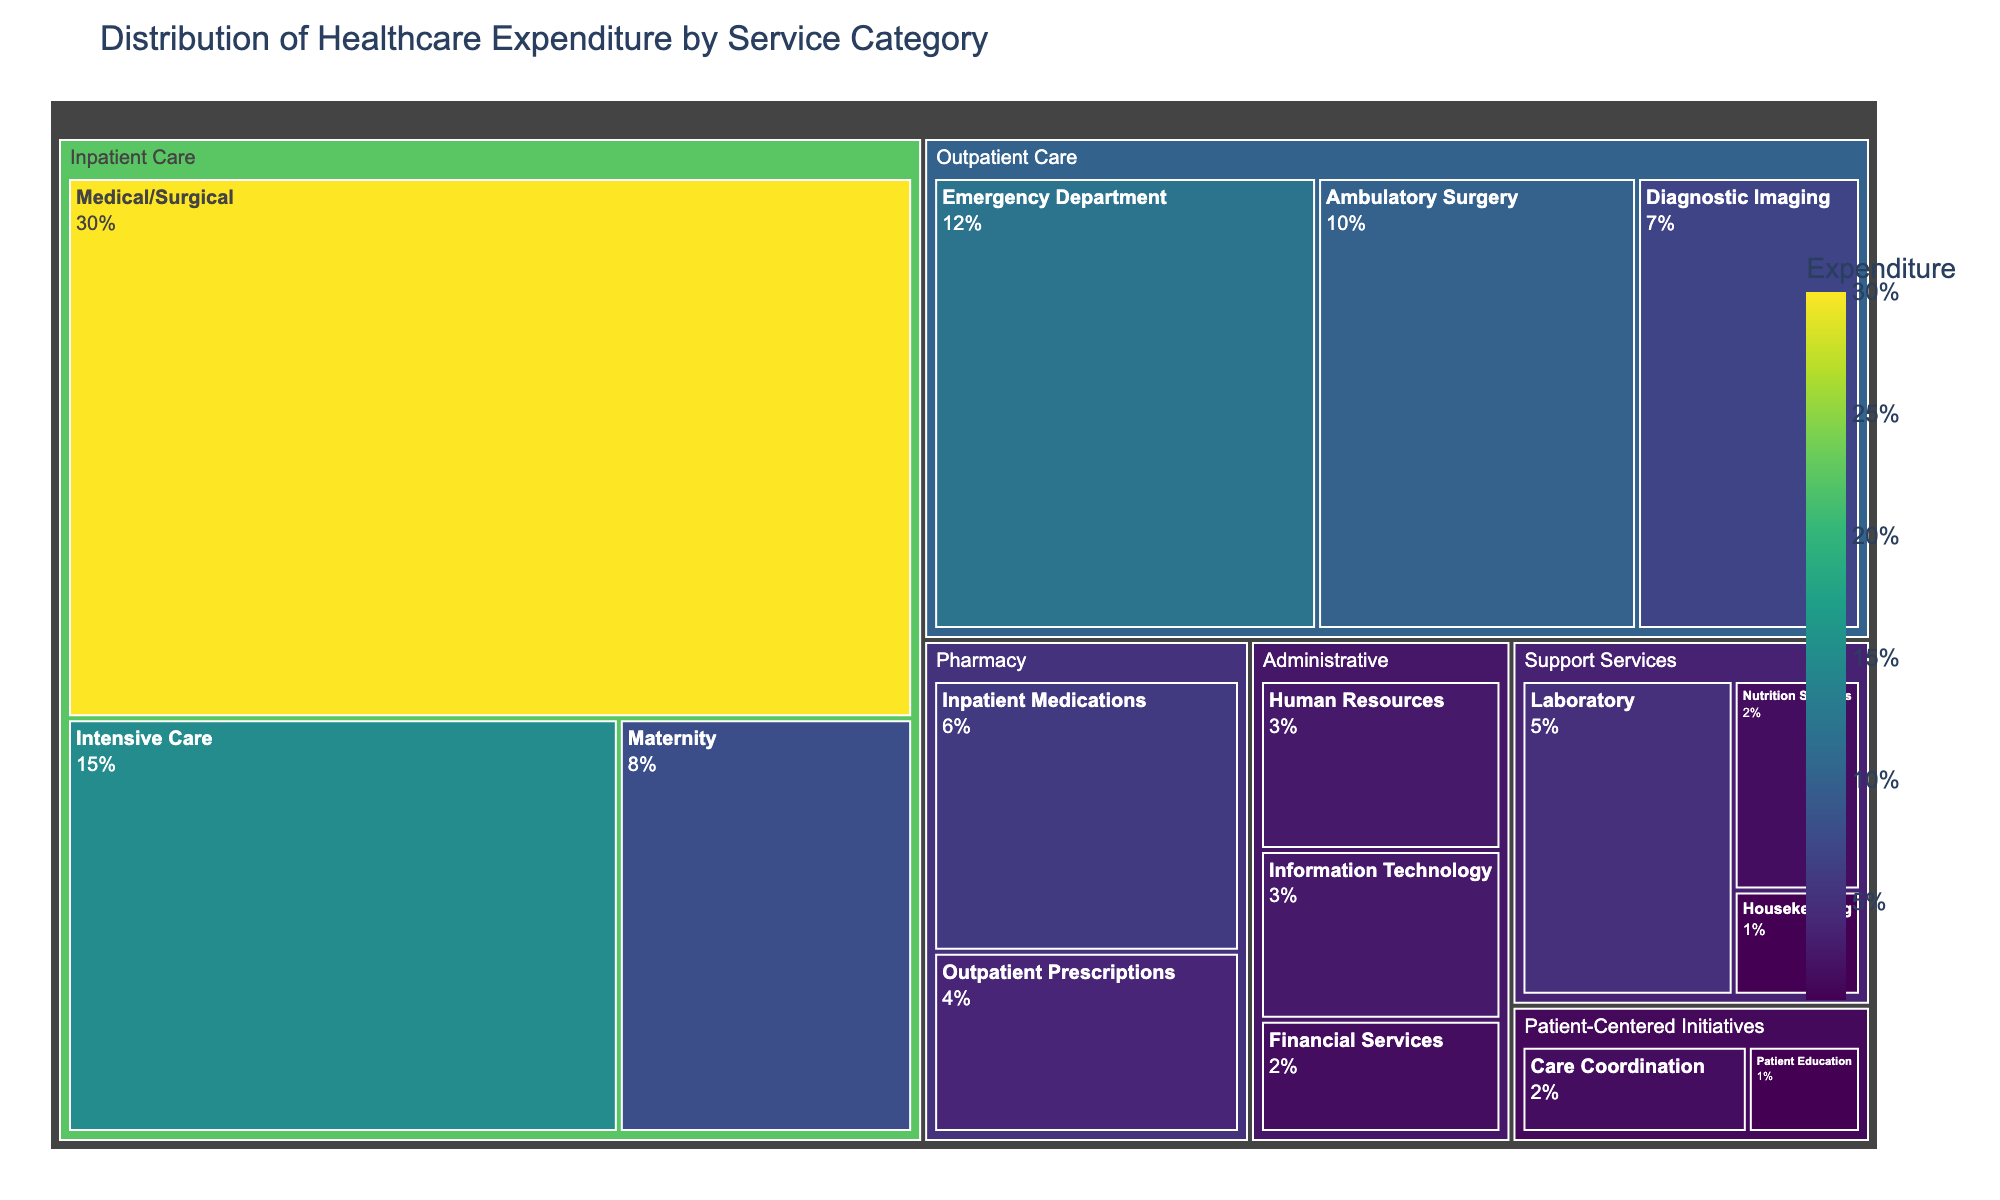What is the title of the figure? The title is located at the top of the figure and reads "Distribution of Healthcare Expenditure by Service Category."
Answer: Distribution of Healthcare Expenditure by Service Category Which category has the highest expenditure? The treemap visually shows the size of each category's block. The largest block represents 'Inpatient Care' with the highest total expenditure.
Answer: Inpatient Care How much expenditure is allocated to 'Emergency Department'? Locate 'Emergency Department' within the 'Outpatient Care' section in the treemap. The associated block indicates an expenditure of 12%.
Answer: 12% What is the combined expenditure of 'Pharmacy' and 'Administrative' categories? Calculate the sum of the expenditures for 'Pharmacy' (6+4) and 'Administrative' (3+2+3). Pharmacy totals 10% and Administrative totals 8%. Together, they sum up to 18%.
Answer: 18% Which subcategory within 'Support Services' has the least expenditure? In the 'Support Services' section of the treemap, 'Housekeeping' is the smallest block, indicating the least expenditure.
Answer: Housekeeping How does the expenditure on 'Financial Services' compare to 'Information Technology'? Look at the sizes of the blocks for 'Financial Services' and 'Information Technology' within the 'Administrative' category. Both have an expenditure value of 2% and 3%, respectively, so Financial Services is less.
Answer: Financial Services has less expenditure than Information Technology What percentage of the total expenditure is allocated to 'Patient Education'? Locate 'Patient Education' under 'Patient-Centered Initiatives'. The block indicates an expenditure of 1%.
Answer: 1% Is the expenditure for 'Ambulatory Surgery' greater than 'Diagnostic Imaging'? Within the 'Outpatient Care' section, compare the block sizes for 'Ambulatory Surgery' (10%) and 'Diagnostic Imaging' (7%). Ambulatory Surgery has a greater expenditure.
Answer: Yes What is the expenditure difference between 'Medical/Surgical' and 'Intensive Care' under 'Inpatient Care'? Find the blocks for 'Medical/Surgical' (30%) and 'Intensive Care' (15%) under 'Inpatient Care'. Subtracting these, the difference is 15%.
Answer: 15% Among 'Support Services', which has the highest expenditure? 'Laboratory' within the 'Support Services' section is the largest block, indicating the highest expenditure of 5%.
Answer: Laboratory 